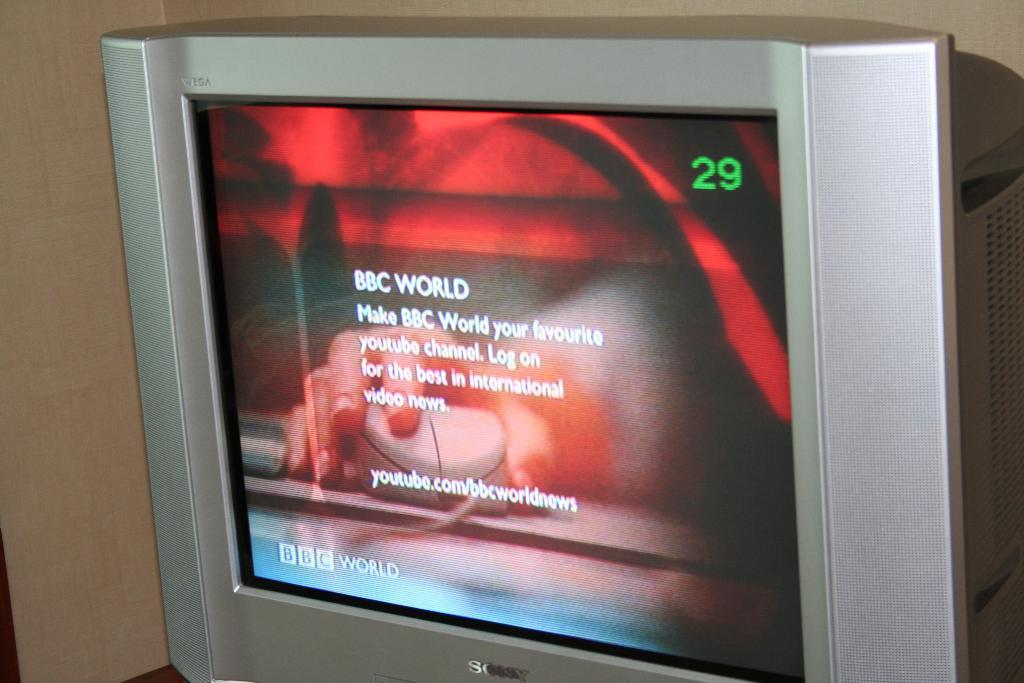<image>
Describe the image concisely. An old fashioned tank type Sony TV tuned to channel 29. 